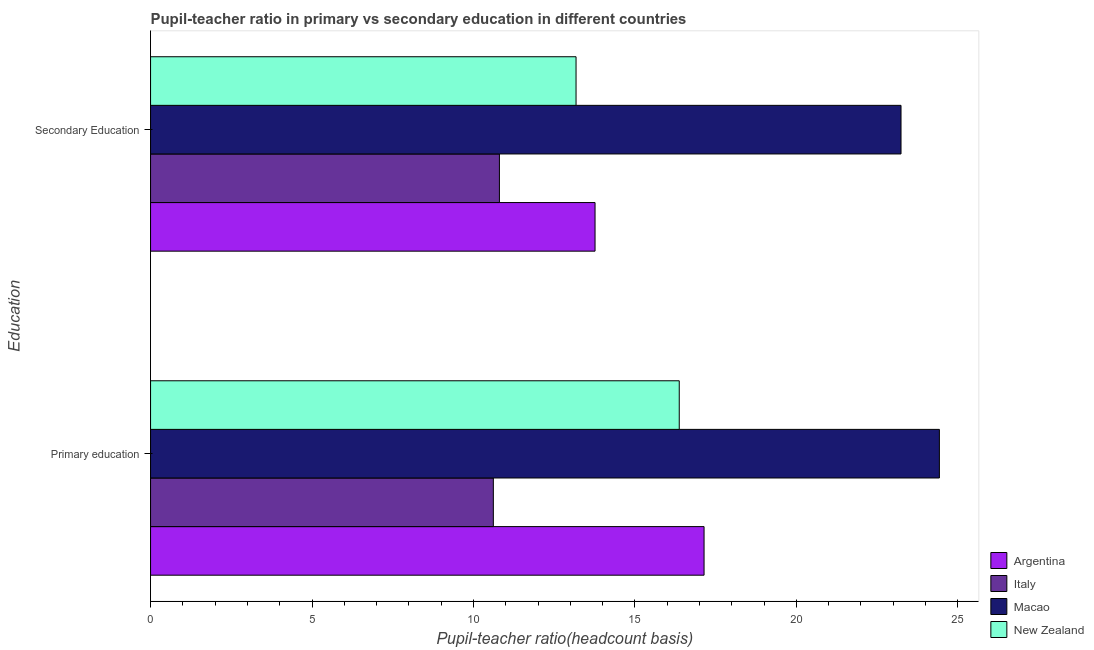How many different coloured bars are there?
Offer a terse response. 4. How many groups of bars are there?
Give a very brief answer. 2. Are the number of bars per tick equal to the number of legend labels?
Make the answer very short. Yes. How many bars are there on the 1st tick from the top?
Keep it short and to the point. 4. What is the label of the 2nd group of bars from the top?
Offer a very short reply. Primary education. What is the pupil-teacher ratio in primary education in Macao?
Your answer should be very brief. 24.43. Across all countries, what is the maximum pupil teacher ratio on secondary education?
Give a very brief answer. 23.24. Across all countries, what is the minimum pupil-teacher ratio in primary education?
Keep it short and to the point. 10.62. In which country was the pupil-teacher ratio in primary education maximum?
Give a very brief answer. Macao. In which country was the pupil-teacher ratio in primary education minimum?
Your answer should be very brief. Italy. What is the total pupil teacher ratio on secondary education in the graph?
Keep it short and to the point. 60.99. What is the difference between the pupil teacher ratio on secondary education in New Zealand and that in Macao?
Ensure brevity in your answer.  -10.06. What is the difference between the pupil-teacher ratio in primary education in Macao and the pupil teacher ratio on secondary education in Argentina?
Give a very brief answer. 10.67. What is the average pupil teacher ratio on secondary education per country?
Give a very brief answer. 15.25. What is the difference between the pupil teacher ratio on secondary education and pupil-teacher ratio in primary education in New Zealand?
Make the answer very short. -3.2. What is the ratio of the pupil teacher ratio on secondary education in Italy to that in New Zealand?
Ensure brevity in your answer.  0.82. Is the pupil-teacher ratio in primary education in New Zealand less than that in Macao?
Provide a short and direct response. Yes. What does the 2nd bar from the top in Secondary Education represents?
Make the answer very short. Macao. What does the 1st bar from the bottom in Secondary Education represents?
Your answer should be very brief. Argentina. How many bars are there?
Offer a terse response. 8. How many countries are there in the graph?
Make the answer very short. 4. What is the difference between two consecutive major ticks on the X-axis?
Provide a short and direct response. 5. Does the graph contain any zero values?
Give a very brief answer. No. Where does the legend appear in the graph?
Offer a very short reply. Bottom right. How are the legend labels stacked?
Offer a terse response. Vertical. What is the title of the graph?
Provide a short and direct response. Pupil-teacher ratio in primary vs secondary education in different countries. What is the label or title of the X-axis?
Offer a terse response. Pupil-teacher ratio(headcount basis). What is the label or title of the Y-axis?
Your answer should be very brief. Education. What is the Pupil-teacher ratio(headcount basis) in Argentina in Primary education?
Give a very brief answer. 17.14. What is the Pupil-teacher ratio(headcount basis) of Italy in Primary education?
Ensure brevity in your answer.  10.62. What is the Pupil-teacher ratio(headcount basis) in Macao in Primary education?
Provide a succinct answer. 24.43. What is the Pupil-teacher ratio(headcount basis) of New Zealand in Primary education?
Your answer should be very brief. 16.37. What is the Pupil-teacher ratio(headcount basis) in Argentina in Secondary Education?
Give a very brief answer. 13.77. What is the Pupil-teacher ratio(headcount basis) of Italy in Secondary Education?
Your response must be concise. 10.8. What is the Pupil-teacher ratio(headcount basis) in Macao in Secondary Education?
Give a very brief answer. 23.24. What is the Pupil-teacher ratio(headcount basis) of New Zealand in Secondary Education?
Offer a very short reply. 13.18. Across all Education, what is the maximum Pupil-teacher ratio(headcount basis) of Argentina?
Give a very brief answer. 17.14. Across all Education, what is the maximum Pupil-teacher ratio(headcount basis) in Italy?
Keep it short and to the point. 10.8. Across all Education, what is the maximum Pupil-teacher ratio(headcount basis) of Macao?
Offer a very short reply. 24.43. Across all Education, what is the maximum Pupil-teacher ratio(headcount basis) in New Zealand?
Your answer should be very brief. 16.37. Across all Education, what is the minimum Pupil-teacher ratio(headcount basis) of Argentina?
Your answer should be very brief. 13.77. Across all Education, what is the minimum Pupil-teacher ratio(headcount basis) in Italy?
Your answer should be compact. 10.62. Across all Education, what is the minimum Pupil-teacher ratio(headcount basis) in Macao?
Your answer should be very brief. 23.24. Across all Education, what is the minimum Pupil-teacher ratio(headcount basis) of New Zealand?
Provide a succinct answer. 13.18. What is the total Pupil-teacher ratio(headcount basis) of Argentina in the graph?
Give a very brief answer. 30.91. What is the total Pupil-teacher ratio(headcount basis) of Italy in the graph?
Provide a succinct answer. 21.42. What is the total Pupil-teacher ratio(headcount basis) in Macao in the graph?
Your answer should be very brief. 47.67. What is the total Pupil-teacher ratio(headcount basis) of New Zealand in the graph?
Your answer should be very brief. 29.55. What is the difference between the Pupil-teacher ratio(headcount basis) of Argentina in Primary education and that in Secondary Education?
Keep it short and to the point. 3.38. What is the difference between the Pupil-teacher ratio(headcount basis) of Italy in Primary education and that in Secondary Education?
Ensure brevity in your answer.  -0.19. What is the difference between the Pupil-teacher ratio(headcount basis) of Macao in Primary education and that in Secondary Education?
Your answer should be compact. 1.19. What is the difference between the Pupil-teacher ratio(headcount basis) in New Zealand in Primary education and that in Secondary Education?
Offer a terse response. 3.2. What is the difference between the Pupil-teacher ratio(headcount basis) of Argentina in Primary education and the Pupil-teacher ratio(headcount basis) of Italy in Secondary Education?
Keep it short and to the point. 6.34. What is the difference between the Pupil-teacher ratio(headcount basis) in Argentina in Primary education and the Pupil-teacher ratio(headcount basis) in Macao in Secondary Education?
Offer a very short reply. -6.1. What is the difference between the Pupil-teacher ratio(headcount basis) in Argentina in Primary education and the Pupil-teacher ratio(headcount basis) in New Zealand in Secondary Education?
Offer a terse response. 3.96. What is the difference between the Pupil-teacher ratio(headcount basis) in Italy in Primary education and the Pupil-teacher ratio(headcount basis) in Macao in Secondary Education?
Make the answer very short. -12.63. What is the difference between the Pupil-teacher ratio(headcount basis) of Italy in Primary education and the Pupil-teacher ratio(headcount basis) of New Zealand in Secondary Education?
Offer a terse response. -2.56. What is the difference between the Pupil-teacher ratio(headcount basis) of Macao in Primary education and the Pupil-teacher ratio(headcount basis) of New Zealand in Secondary Education?
Keep it short and to the point. 11.25. What is the average Pupil-teacher ratio(headcount basis) of Argentina per Education?
Your answer should be very brief. 15.45. What is the average Pupil-teacher ratio(headcount basis) in Italy per Education?
Offer a terse response. 10.71. What is the average Pupil-teacher ratio(headcount basis) in Macao per Education?
Keep it short and to the point. 23.84. What is the average Pupil-teacher ratio(headcount basis) in New Zealand per Education?
Offer a terse response. 14.78. What is the difference between the Pupil-teacher ratio(headcount basis) of Argentina and Pupil-teacher ratio(headcount basis) of Italy in Primary education?
Your answer should be compact. 6.53. What is the difference between the Pupil-teacher ratio(headcount basis) in Argentina and Pupil-teacher ratio(headcount basis) in Macao in Primary education?
Your answer should be very brief. -7.29. What is the difference between the Pupil-teacher ratio(headcount basis) of Argentina and Pupil-teacher ratio(headcount basis) of New Zealand in Primary education?
Your answer should be compact. 0.77. What is the difference between the Pupil-teacher ratio(headcount basis) in Italy and Pupil-teacher ratio(headcount basis) in Macao in Primary education?
Provide a succinct answer. -13.82. What is the difference between the Pupil-teacher ratio(headcount basis) of Italy and Pupil-teacher ratio(headcount basis) of New Zealand in Primary education?
Offer a terse response. -5.76. What is the difference between the Pupil-teacher ratio(headcount basis) of Macao and Pupil-teacher ratio(headcount basis) of New Zealand in Primary education?
Make the answer very short. 8.06. What is the difference between the Pupil-teacher ratio(headcount basis) of Argentina and Pupil-teacher ratio(headcount basis) of Italy in Secondary Education?
Offer a very short reply. 2.96. What is the difference between the Pupil-teacher ratio(headcount basis) of Argentina and Pupil-teacher ratio(headcount basis) of Macao in Secondary Education?
Your answer should be compact. -9.48. What is the difference between the Pupil-teacher ratio(headcount basis) of Argentina and Pupil-teacher ratio(headcount basis) of New Zealand in Secondary Education?
Keep it short and to the point. 0.59. What is the difference between the Pupil-teacher ratio(headcount basis) in Italy and Pupil-teacher ratio(headcount basis) in Macao in Secondary Education?
Offer a terse response. -12.44. What is the difference between the Pupil-teacher ratio(headcount basis) in Italy and Pupil-teacher ratio(headcount basis) in New Zealand in Secondary Education?
Offer a very short reply. -2.37. What is the difference between the Pupil-teacher ratio(headcount basis) in Macao and Pupil-teacher ratio(headcount basis) in New Zealand in Secondary Education?
Your response must be concise. 10.06. What is the ratio of the Pupil-teacher ratio(headcount basis) of Argentina in Primary education to that in Secondary Education?
Give a very brief answer. 1.25. What is the ratio of the Pupil-teacher ratio(headcount basis) of Italy in Primary education to that in Secondary Education?
Provide a succinct answer. 0.98. What is the ratio of the Pupil-teacher ratio(headcount basis) of Macao in Primary education to that in Secondary Education?
Keep it short and to the point. 1.05. What is the ratio of the Pupil-teacher ratio(headcount basis) of New Zealand in Primary education to that in Secondary Education?
Ensure brevity in your answer.  1.24. What is the difference between the highest and the second highest Pupil-teacher ratio(headcount basis) of Argentina?
Your answer should be compact. 3.38. What is the difference between the highest and the second highest Pupil-teacher ratio(headcount basis) of Italy?
Your answer should be very brief. 0.19. What is the difference between the highest and the second highest Pupil-teacher ratio(headcount basis) of Macao?
Provide a succinct answer. 1.19. What is the difference between the highest and the second highest Pupil-teacher ratio(headcount basis) of New Zealand?
Make the answer very short. 3.2. What is the difference between the highest and the lowest Pupil-teacher ratio(headcount basis) of Argentina?
Keep it short and to the point. 3.38. What is the difference between the highest and the lowest Pupil-teacher ratio(headcount basis) of Italy?
Keep it short and to the point. 0.19. What is the difference between the highest and the lowest Pupil-teacher ratio(headcount basis) in Macao?
Provide a succinct answer. 1.19. What is the difference between the highest and the lowest Pupil-teacher ratio(headcount basis) of New Zealand?
Your answer should be compact. 3.2. 